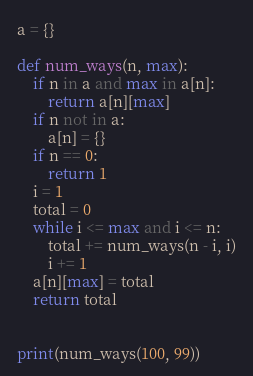<code> <loc_0><loc_0><loc_500><loc_500><_Python_>a = {}

def num_ways(n, max):
    if n in a and max in a[n]:
        return a[n][max]
    if n not in a:
        a[n] = {}
    if n == 0:
        return 1
    i = 1
    total = 0
    while i <= max and i <= n:
        total += num_ways(n - i, i)
        i += 1
    a[n][max] = total
    return total


print(num_ways(100, 99))
</code> 